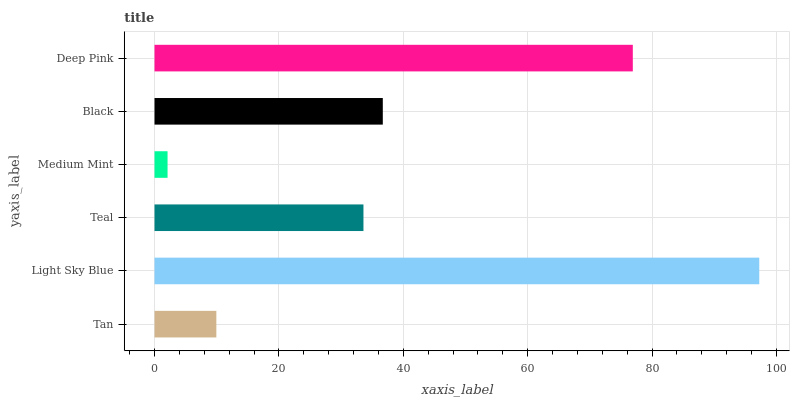Is Medium Mint the minimum?
Answer yes or no. Yes. Is Light Sky Blue the maximum?
Answer yes or no. Yes. Is Teal the minimum?
Answer yes or no. No. Is Teal the maximum?
Answer yes or no. No. Is Light Sky Blue greater than Teal?
Answer yes or no. Yes. Is Teal less than Light Sky Blue?
Answer yes or no. Yes. Is Teal greater than Light Sky Blue?
Answer yes or no. No. Is Light Sky Blue less than Teal?
Answer yes or no. No. Is Black the high median?
Answer yes or no. Yes. Is Teal the low median?
Answer yes or no. Yes. Is Teal the high median?
Answer yes or no. No. Is Deep Pink the low median?
Answer yes or no. No. 